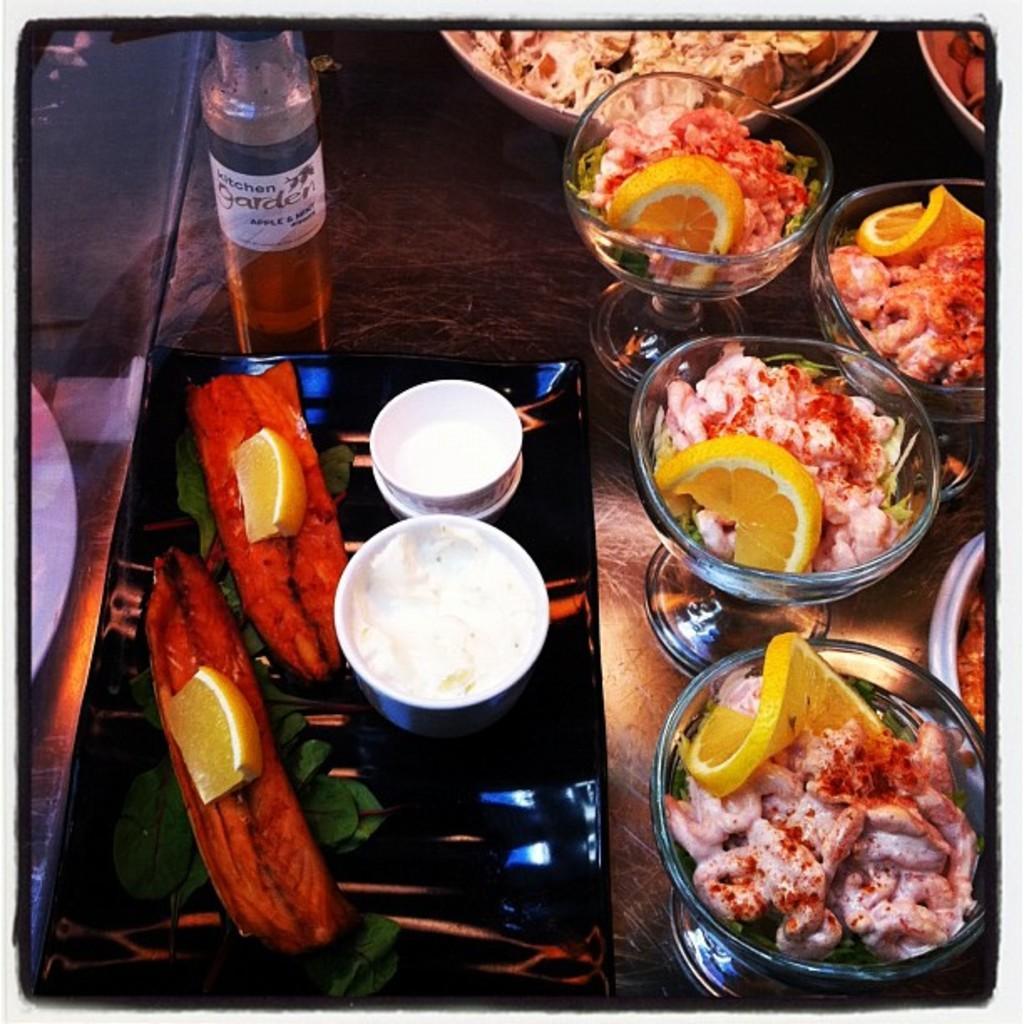Describe this image in one or two sentences. In this picture we can see some food items and bowls on a tray. There are food items in the glasses and plates. There is a glass. We can see the reflection of a white object on the glass. 